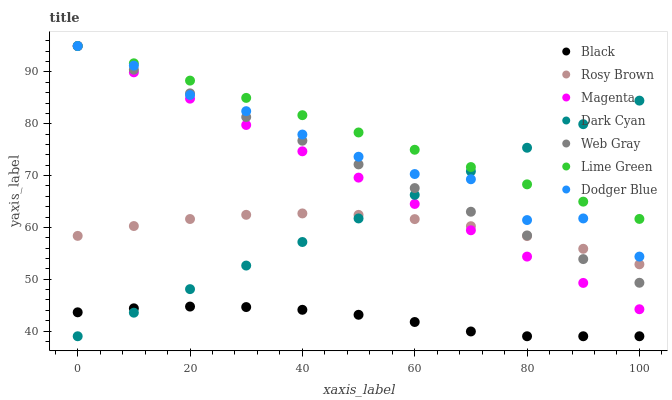Does Black have the minimum area under the curve?
Answer yes or no. Yes. Does Lime Green have the maximum area under the curve?
Answer yes or no. Yes. Does Rosy Brown have the minimum area under the curve?
Answer yes or no. No. Does Rosy Brown have the maximum area under the curve?
Answer yes or no. No. Is Dark Cyan the smoothest?
Answer yes or no. Yes. Is Dodger Blue the roughest?
Answer yes or no. Yes. Is Rosy Brown the smoothest?
Answer yes or no. No. Is Rosy Brown the roughest?
Answer yes or no. No. Does Black have the lowest value?
Answer yes or no. Yes. Does Rosy Brown have the lowest value?
Answer yes or no. No. Does Lime Green have the highest value?
Answer yes or no. Yes. Does Rosy Brown have the highest value?
Answer yes or no. No. Is Rosy Brown less than Lime Green?
Answer yes or no. Yes. Is Rosy Brown greater than Black?
Answer yes or no. Yes. Does Black intersect Dark Cyan?
Answer yes or no. Yes. Is Black less than Dark Cyan?
Answer yes or no. No. Is Black greater than Dark Cyan?
Answer yes or no. No. Does Rosy Brown intersect Lime Green?
Answer yes or no. No. 